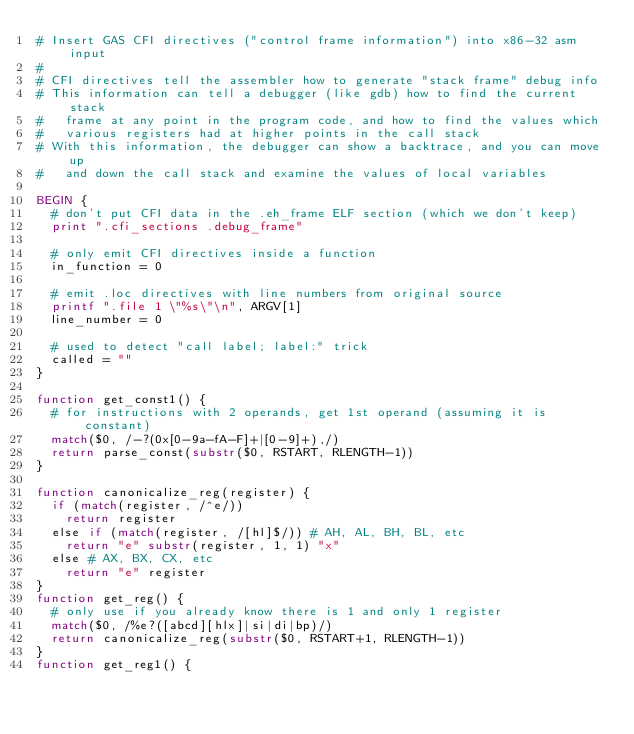Convert code to text. <code><loc_0><loc_0><loc_500><loc_500><_Awk_># Insert GAS CFI directives ("control frame information") into x86-32 asm input
#
# CFI directives tell the assembler how to generate "stack frame" debug info
# This information can tell a debugger (like gdb) how to find the current stack
#   frame at any point in the program code, and how to find the values which
#   various registers had at higher points in the call stack
# With this information, the debugger can show a backtrace, and you can move up
#   and down the call stack and examine the values of local variables

BEGIN {
  # don't put CFI data in the .eh_frame ELF section (which we don't keep)
  print ".cfi_sections .debug_frame"

  # only emit CFI directives inside a function
  in_function = 0

  # emit .loc directives with line numbers from original source
  printf ".file 1 \"%s\"\n", ARGV[1]
  line_number = 0

  # used to detect "call label; label:" trick
  called = ""
}

function get_const1() {
  # for instructions with 2 operands, get 1st operand (assuming it is constant)
  match($0, /-?(0x[0-9a-fA-F]+|[0-9]+),/)
  return parse_const(substr($0, RSTART, RLENGTH-1))
}

function canonicalize_reg(register) {
  if (match(register, /^e/))
    return register
  else if (match(register, /[hl]$/)) # AH, AL, BH, BL, etc
    return "e" substr(register, 1, 1) "x"
  else # AX, BX, CX, etc
    return "e" register
}
function get_reg() {
  # only use if you already know there is 1 and only 1 register
  match($0, /%e?([abcd][hlx]|si|di|bp)/)
  return canonicalize_reg(substr($0, RSTART+1, RLENGTH-1))
}
function get_reg1() {</code> 